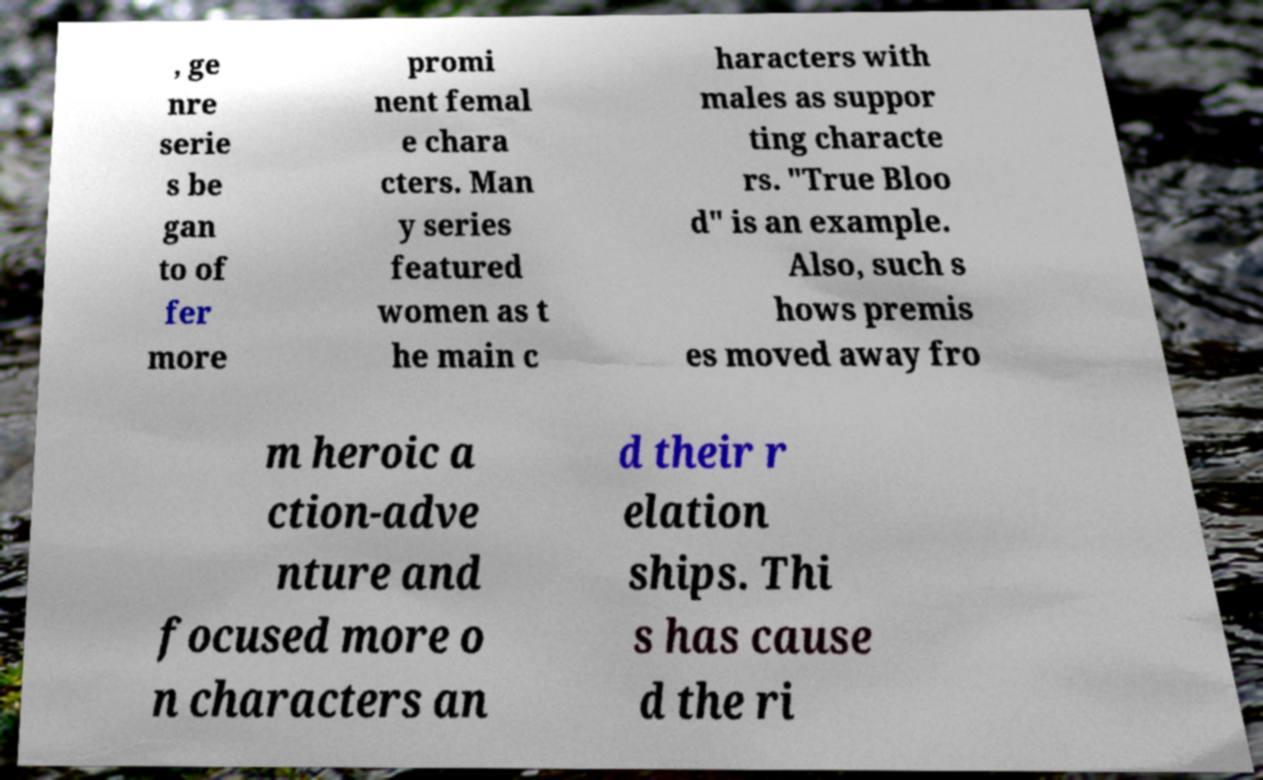I need the written content from this picture converted into text. Can you do that? , ge nre serie s be gan to of fer more promi nent femal e chara cters. Man y series featured women as t he main c haracters with males as suppor ting characte rs. "True Bloo d" is an example. Also, such s hows premis es moved away fro m heroic a ction-adve nture and focused more o n characters an d their r elation ships. Thi s has cause d the ri 